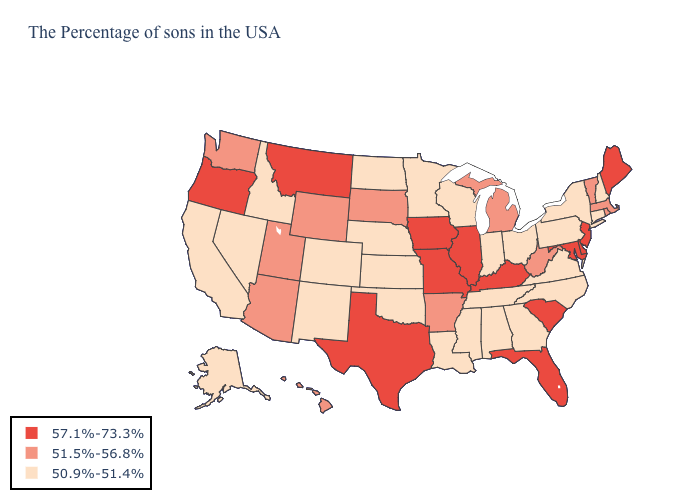What is the lowest value in states that border South Carolina?
Concise answer only. 50.9%-51.4%. Among the states that border Pennsylvania , which have the highest value?
Be succinct. New Jersey, Delaware, Maryland. How many symbols are there in the legend?
Answer briefly. 3. Does Texas have the highest value in the South?
Concise answer only. Yes. Among the states that border South Dakota , does Montana have the lowest value?
Write a very short answer. No. Which states have the lowest value in the USA?
Give a very brief answer. New Hampshire, Connecticut, New York, Pennsylvania, Virginia, North Carolina, Ohio, Georgia, Indiana, Alabama, Tennessee, Wisconsin, Mississippi, Louisiana, Minnesota, Kansas, Nebraska, Oklahoma, North Dakota, Colorado, New Mexico, Idaho, Nevada, California, Alaska. What is the value of Michigan?
Quick response, please. 51.5%-56.8%. Name the states that have a value in the range 51.5%-56.8%?
Be succinct. Massachusetts, Rhode Island, Vermont, West Virginia, Michigan, Arkansas, South Dakota, Wyoming, Utah, Arizona, Washington, Hawaii. Name the states that have a value in the range 57.1%-73.3%?
Short answer required. Maine, New Jersey, Delaware, Maryland, South Carolina, Florida, Kentucky, Illinois, Missouri, Iowa, Texas, Montana, Oregon. What is the lowest value in states that border Washington?
Quick response, please. 50.9%-51.4%. Among the states that border Georgia , does Alabama have the lowest value?
Answer briefly. Yes. What is the value of Florida?
Give a very brief answer. 57.1%-73.3%. What is the value of Wyoming?
Give a very brief answer. 51.5%-56.8%. Which states hav the highest value in the Northeast?
Give a very brief answer. Maine, New Jersey. Is the legend a continuous bar?
Write a very short answer. No. 